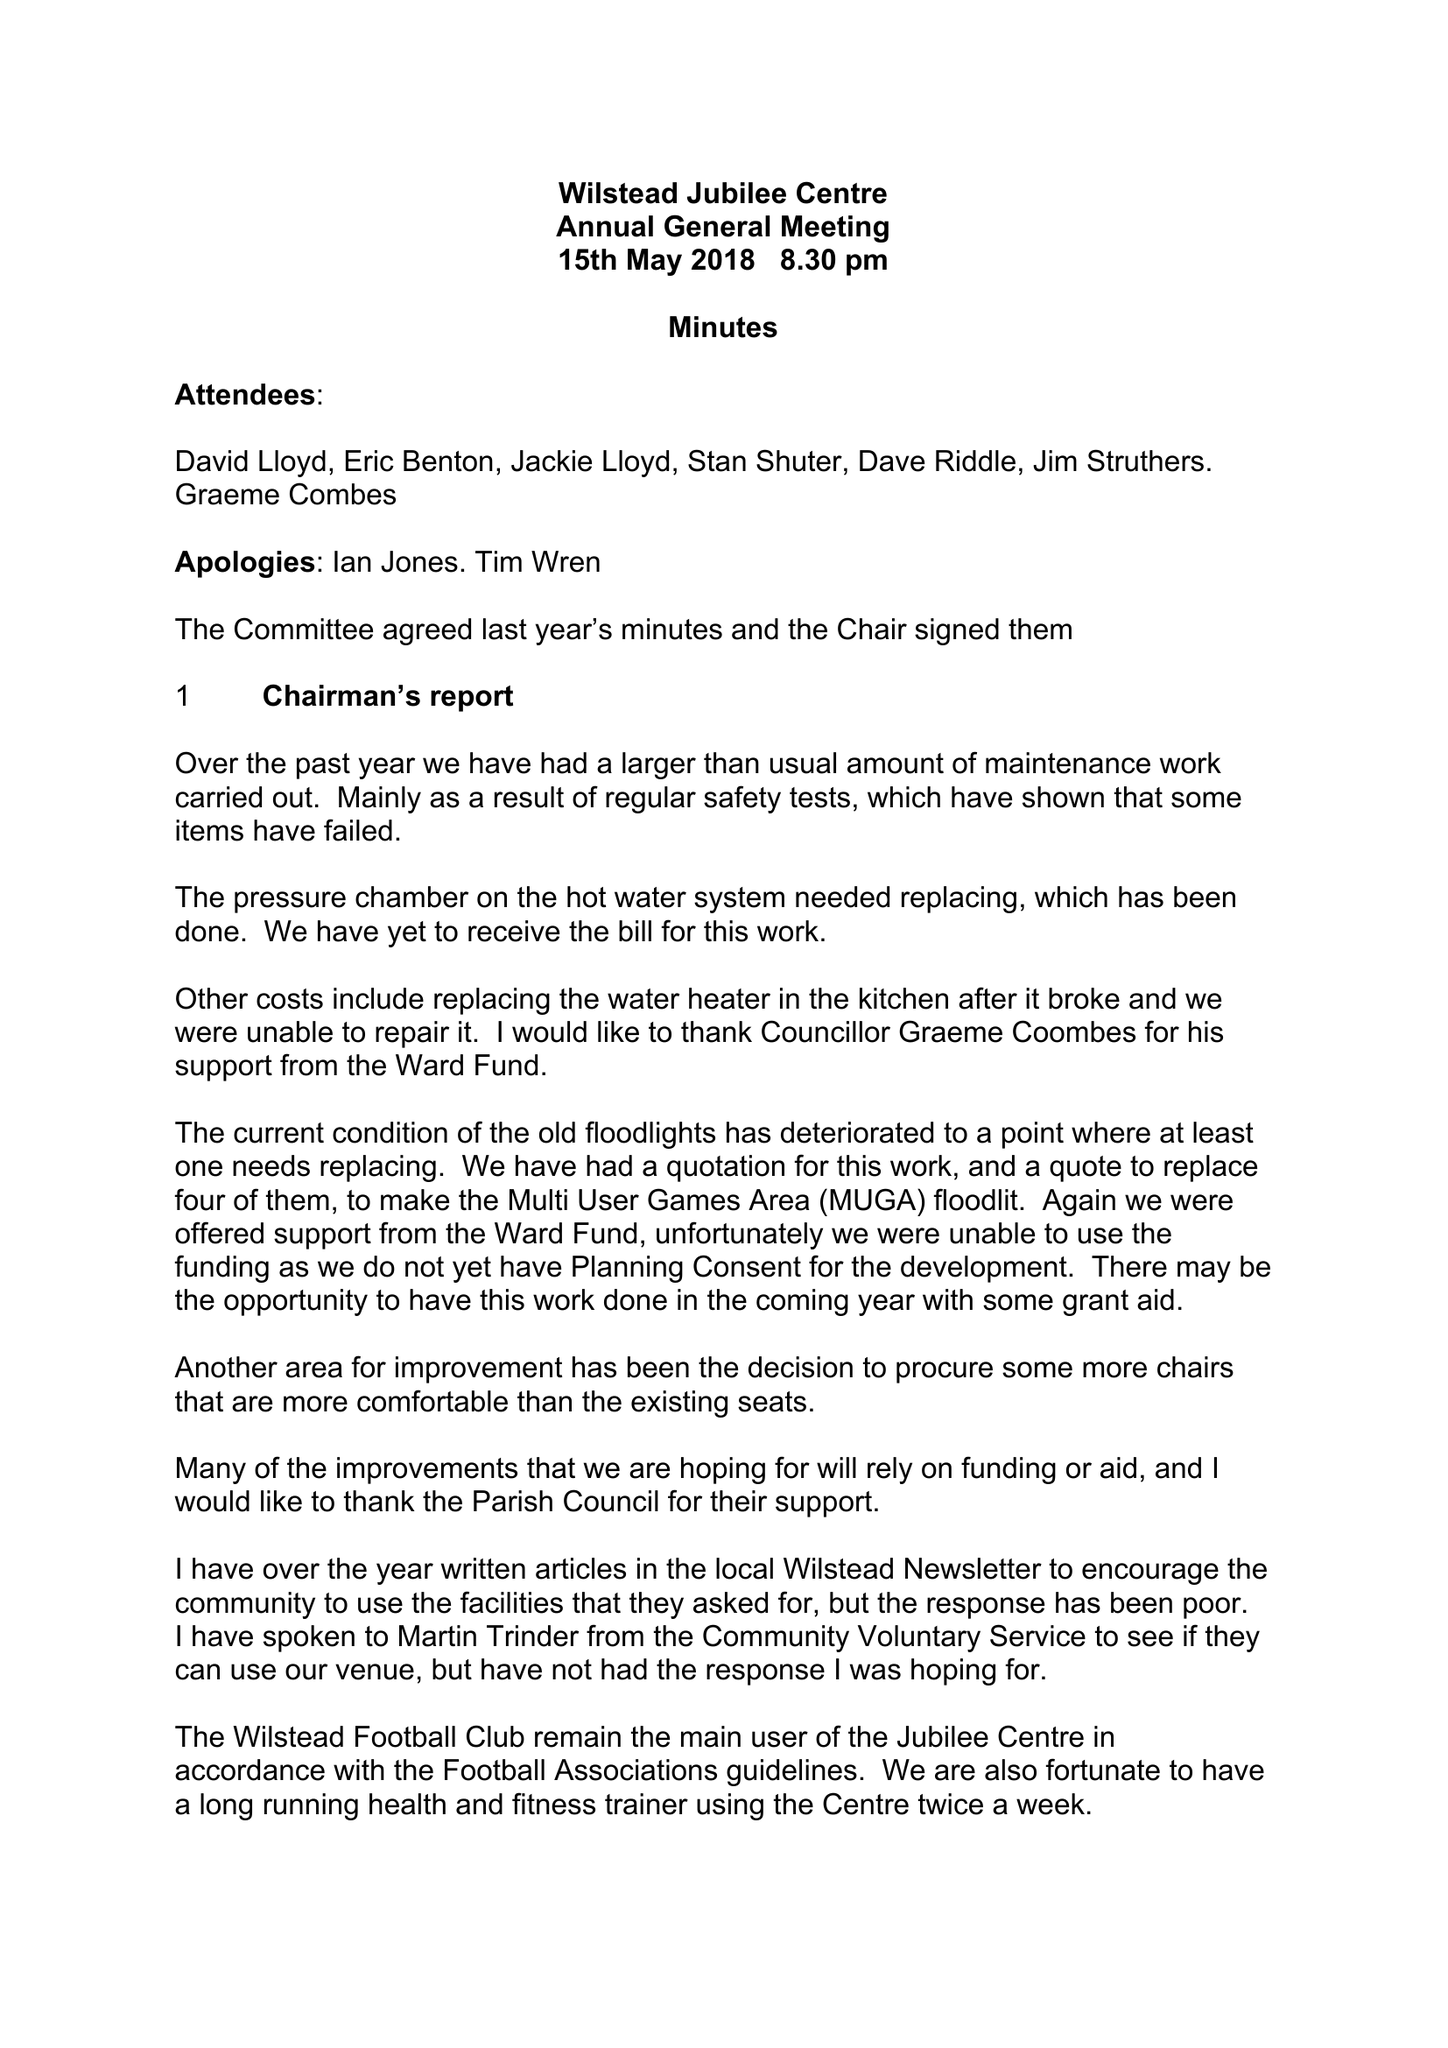What is the value for the address__post_town?
Answer the question using a single word or phrase. BEDFORD 